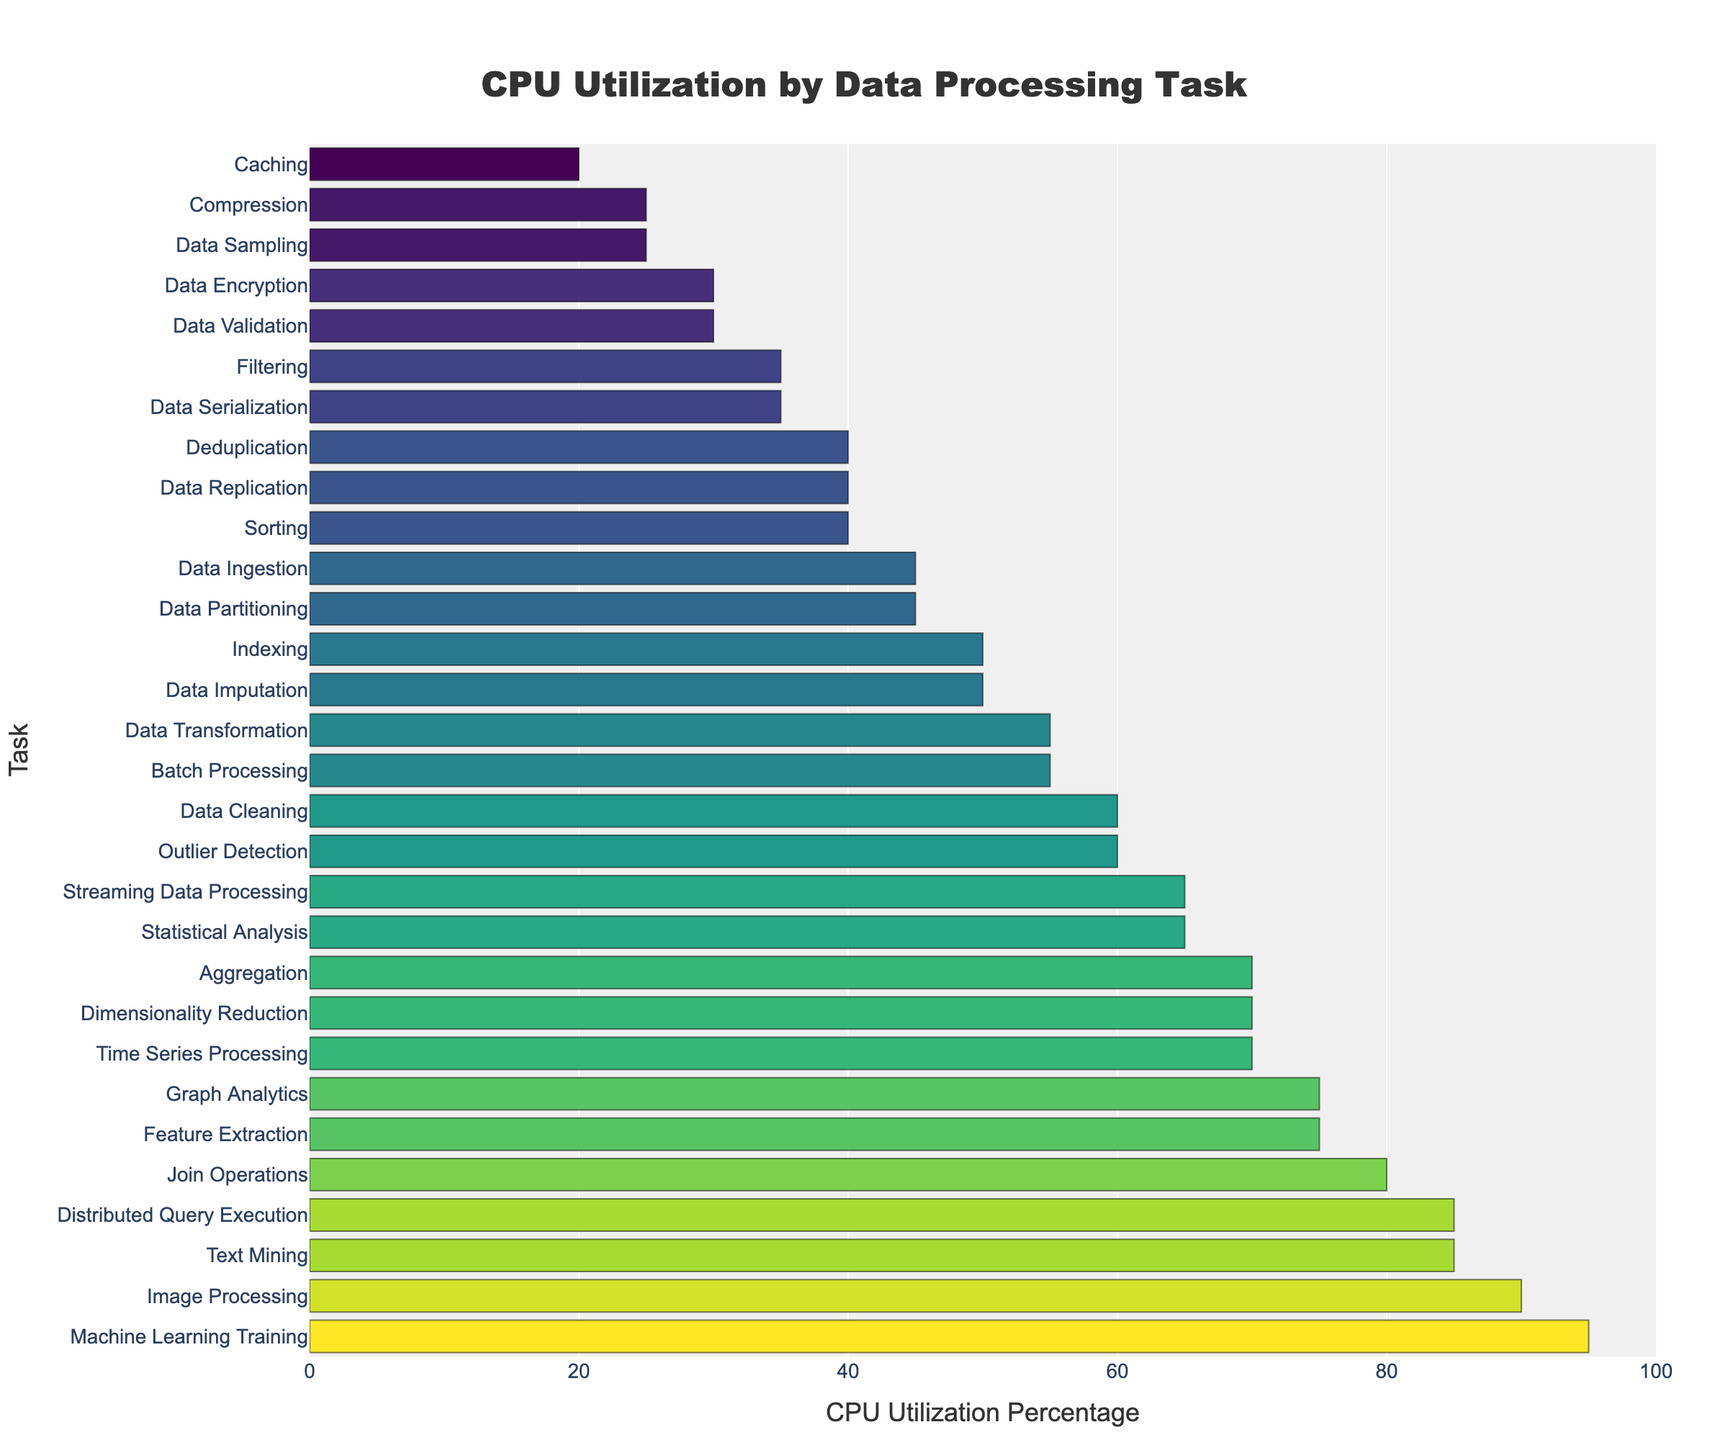Which task has the highest CPU utilization? By looking at the tallest bar in the bar chart, we can see that 'Machine Learning Training' has the highest CPU utilization.
Answer: Machine Learning Training Which two tasks have the lowest CPU utilization? By identifying the two shortest bars in the bar chart, we can observe that 'Caching' and 'Compression' have the lowest CPU utilization percentages.
Answer: Caching and Compression What is the median CPU utilization percentage of all tasks? To determine the median, we need to list all the CPU utilization percentages in ascending order and find the middle value. Given that there are 30 tasks, the median will be the average of the 15th and 16th values.
Answer: 55 How much higher is the CPU utilization for 'Join Operations' compared to 'Data Sorting'? First, find the CPU utilization percentages for 'Join Operations' (80%) and 'Data Sorting' (40%). Then subtract the value of 'Data Sorting' from 'Join Operations' (80 - 40).
Answer: 40 Which task has a lighter shade of color in the bar representing it: 'Data Encryption' or 'Text Mining'? The lighter shade of color in the 'Viridis' color scheme corresponds to lower CPU utilization. By comparing the colors in the chart, 'Data Encryption' has a lighter shade due to its lower CPU utilization (30%) compared to 'Text Mining' (85%).
Answer: Data Encryption Is the CPU utilization for 'Dimensionality Reduction' greater than that of 'Data Transformation'? By looking at the respective heights of the bars, 'Dimensionality Reduction' (70%) has a higher CPU utilization than 'Data Transformation' (55%).
Answer: Yes What is the average CPU utilization of 'Data Cleaning', 'Feature Extraction', and 'Data Transformation'? First, identify the CPU utilization percentages: 'Data Cleaning' (60%), 'Feature Extraction' (75%), and 'Data Transformation' (55%). Add them up and divide by 3 to get the average. (60 + 75 + 55)/3.
Answer: 63.33 Which tasks have a CPU utilization greater than 80%? Identify the tasks with bars higher than 80%: 'Machine Learning Training', 'Text Mining', and 'Distributed Query Execution'.
Answer: Machine Learning Training, Text Mining, Distributed Query Execution What is the CPU utilization difference between 'Data Ingestion' and 'Filtration'? Determine the CPU utilization for each: 'Data Ingestion' (45%) and 'Filtration' (35%). Subtract 'Filtration' from 'Data Ingestion' (45 - 35).
Answer: 10 Which task has equal CPU utilization to 'Statistical Analysis'? By checking the bars with the same height, 'Streaming Data Processing' also has a 65% CPU utilization.
Answer: Streaming Data Processing 